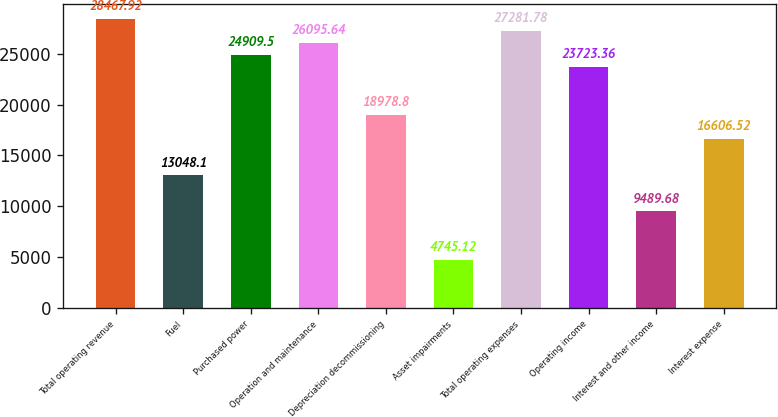<chart> <loc_0><loc_0><loc_500><loc_500><bar_chart><fcel>Total operating revenue<fcel>Fuel<fcel>Purchased power<fcel>Operation and maintenance<fcel>Depreciation decommissioning<fcel>Asset impairments<fcel>Total operating expenses<fcel>Operating income<fcel>Interest and other income<fcel>Interest expense<nl><fcel>28467.9<fcel>13048.1<fcel>24909.5<fcel>26095.6<fcel>18978.8<fcel>4745.12<fcel>27281.8<fcel>23723.4<fcel>9489.68<fcel>16606.5<nl></chart> 